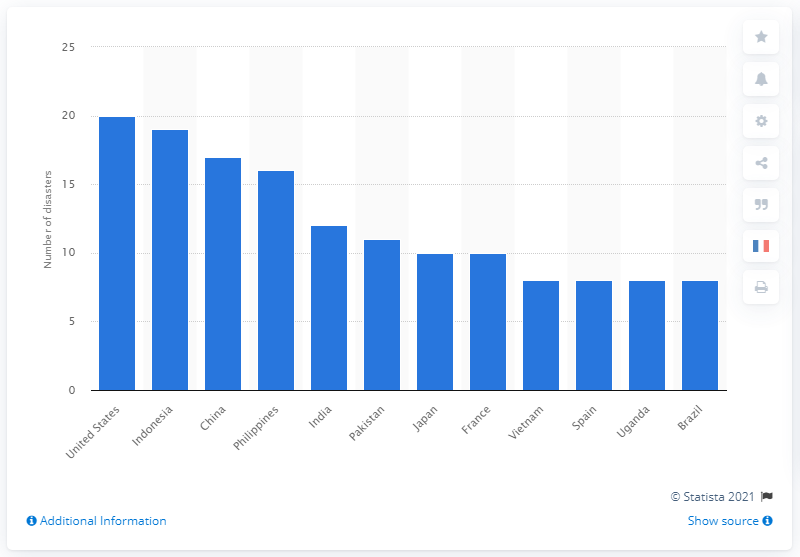List a handful of essential elements in this visual. In 2019, the United States endured 20 natural disasters. 